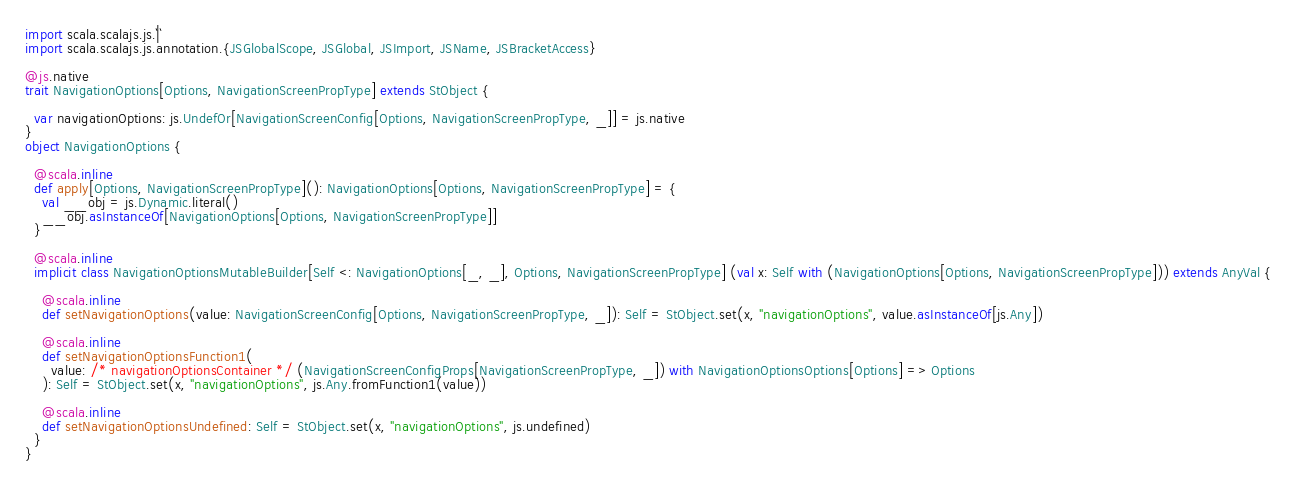Convert code to text. <code><loc_0><loc_0><loc_500><loc_500><_Scala_>import scala.scalajs.js.`|`
import scala.scalajs.js.annotation.{JSGlobalScope, JSGlobal, JSImport, JSName, JSBracketAccess}

@js.native
trait NavigationOptions[Options, NavigationScreenPropType] extends StObject {
  
  var navigationOptions: js.UndefOr[NavigationScreenConfig[Options, NavigationScreenPropType, _]] = js.native
}
object NavigationOptions {
  
  @scala.inline
  def apply[Options, NavigationScreenPropType](): NavigationOptions[Options, NavigationScreenPropType] = {
    val __obj = js.Dynamic.literal()
    __obj.asInstanceOf[NavigationOptions[Options, NavigationScreenPropType]]
  }
  
  @scala.inline
  implicit class NavigationOptionsMutableBuilder[Self <: NavigationOptions[_, _], Options, NavigationScreenPropType] (val x: Self with (NavigationOptions[Options, NavigationScreenPropType])) extends AnyVal {
    
    @scala.inline
    def setNavigationOptions(value: NavigationScreenConfig[Options, NavigationScreenPropType, _]): Self = StObject.set(x, "navigationOptions", value.asInstanceOf[js.Any])
    
    @scala.inline
    def setNavigationOptionsFunction1(
      value: /* navigationOptionsContainer */ (NavigationScreenConfigProps[NavigationScreenPropType, _]) with NavigationOptionsOptions[Options] => Options
    ): Self = StObject.set(x, "navigationOptions", js.Any.fromFunction1(value))
    
    @scala.inline
    def setNavigationOptionsUndefined: Self = StObject.set(x, "navigationOptions", js.undefined)
  }
}
</code> 